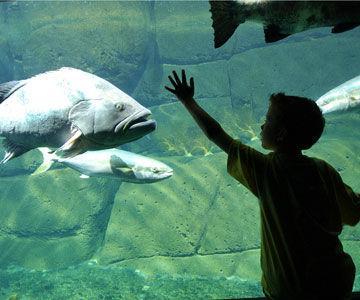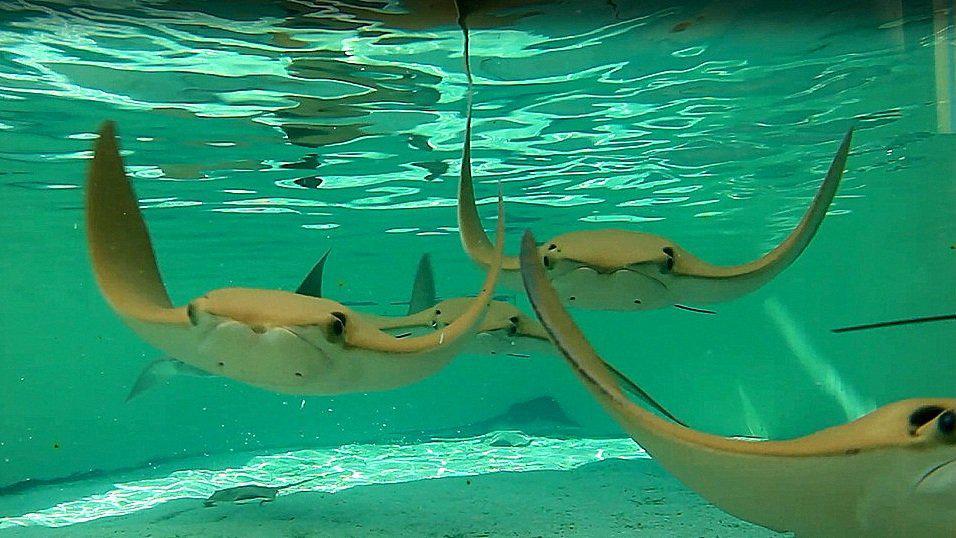The first image is the image on the left, the second image is the image on the right. Assess this claim about the two images: "There are sting rays in both images.". Correct or not? Answer yes or no. No. The first image is the image on the left, the second image is the image on the right. Evaluate the accuracy of this statement regarding the images: "There is a human visible in one of the images.". Is it true? Answer yes or no. Yes. 